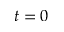Convert formula to latex. <formula><loc_0><loc_0><loc_500><loc_500>t = 0</formula> 